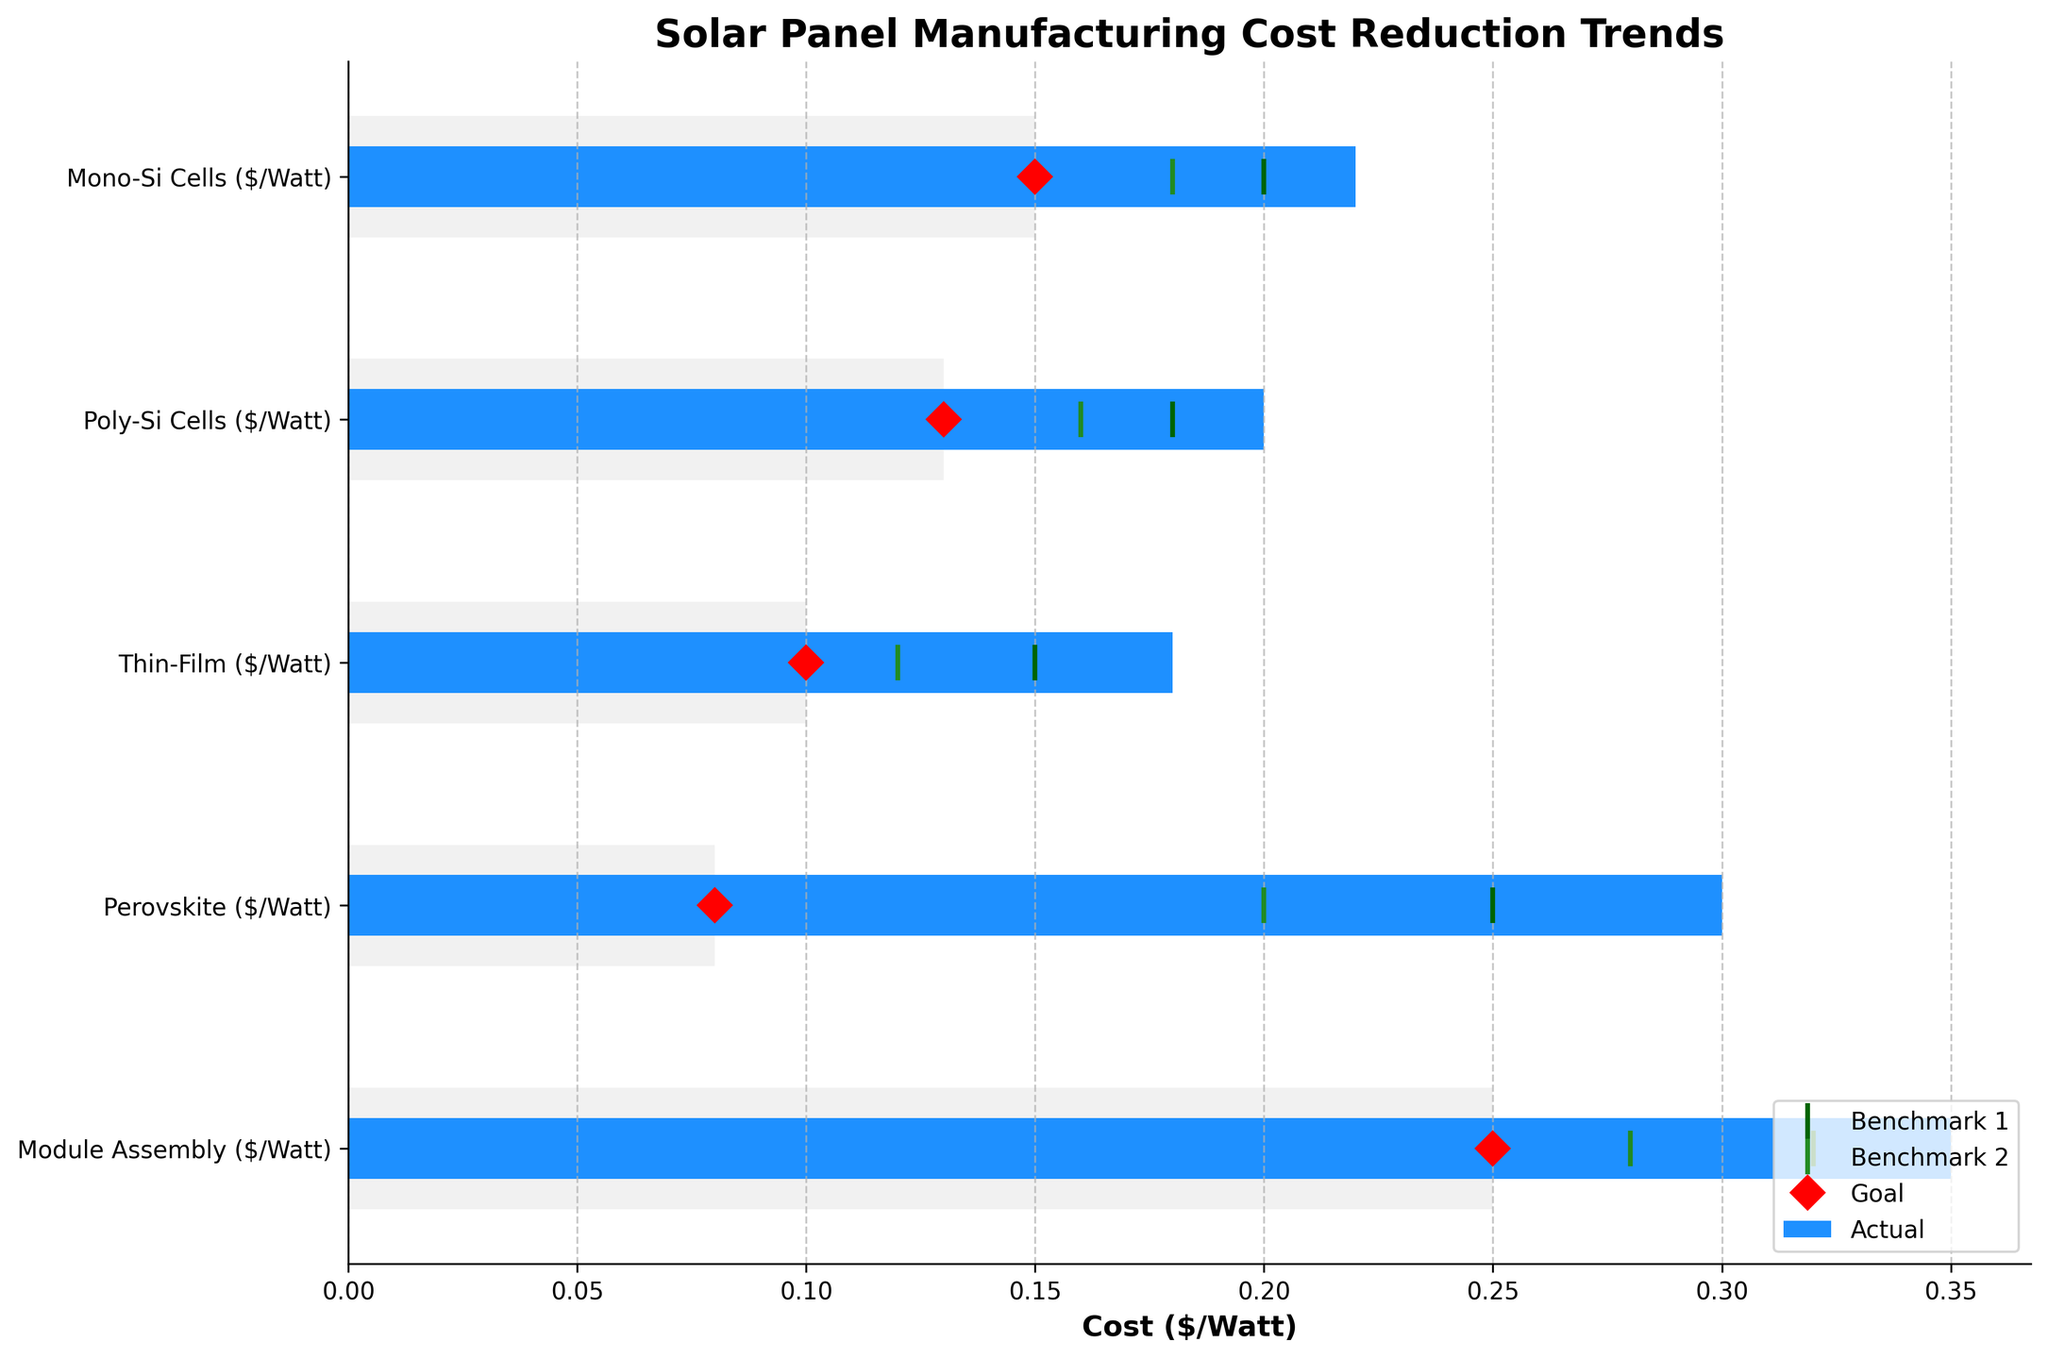What is the title of the figure? The title is shown at the top of the figure, indicating the overall theme or subject it represents.
Answer: Solar Panel Manufacturing Cost Reduction Trends Which solar panel type has the lowest goal cost per watt? Examine the red diamond markers for each category to identify which is the lowest. The Thin-Film category has the lowest red diamond at $0.10 per watt.
Answer: Thin-Film What is the difference between the actual cost and the goal cost for Mono-Si Cells? The actual cost for Mono-Si Cells is $0.22 per watt, and the goal cost is $0.15 per watt. Subtract the goal cost from the actual cost: $0.22 - $0.15 = $0.07.
Answer: $0.07 Which category has the largest gap between the actual cost and Benchmark 2? Compare the differences between actual costs (blue bars) and Benchmark 2 (second green line) for all categories. Perovskite has the largest gap, with actual cost at $0.30 and Benchmark 2 at $0.20, resulting in a gap of $0.10.
Answer: Perovskite How many benchmark lines are there in the figure, and what do they represent? The figure contains two sets of benchmark lines in dark green and forest green colors. Each set corresponds to different intermediate targets for cost reduction.
Answer: Two What is the combined goal cost for Poly-Si Cells and Module Assembly? Add the goal costs for both categories: Poly-Si Cells ($0.13) + Module Assembly ($0.25) = $0.38.
Answer: $0.38 Are any categories already meeting their Benchmark 1 value? Compare the actual (blue bars) with Benchmark 1 (dark green lines). None of the actual values meet or are lower than Benchmark 1 for any category.
Answer: No Which category has the smallest actual cost? Identify the shortest blue bar across all categories. Thin-Film has the smallest actual cost at $0.18 per watt.
Answer: Thin-Film What color represents the actual cost in the figure? Identify the color used for the actual cost bars.
Answer: Dodgerblue Is there any category where the actual cost is closer to the goal cost than to both benchmarks? Compare the proximity of the actual costs (blue bars) to the goal costs (red diamonds) and benchmarks (green lines). For Poly-Si Cells, the actual cost ($0.20) is closer to the goal cost ($0.13) than to both Benchmark 1 ($0.18) and Benchmark 2 ($0.16).
Answer: Poly-Si Cells 